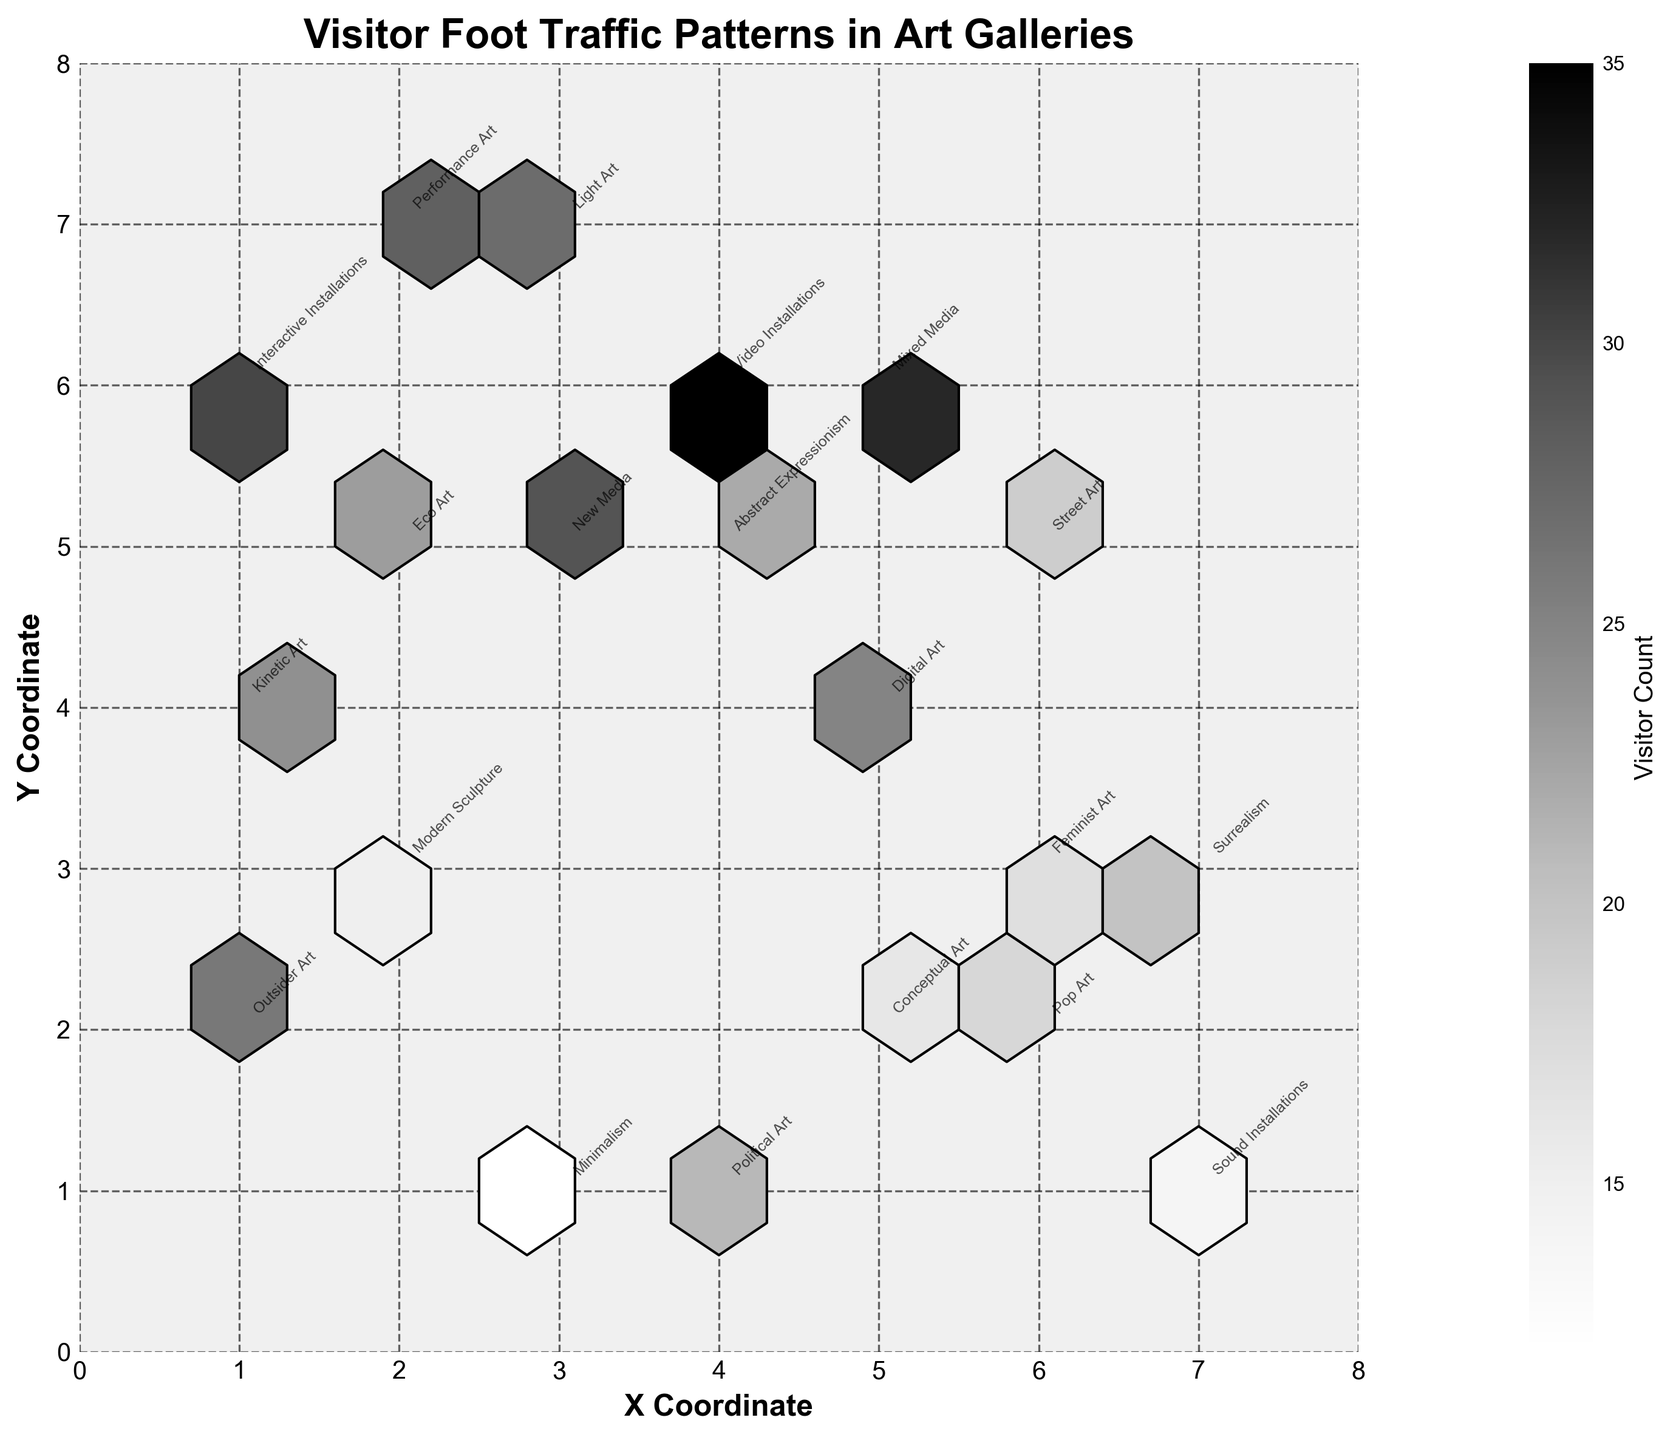What is the title of the plot? The title of the plot is displayed at the top of the figure.
Answer: Visitor Foot Traffic Patterns in Art Galleries What are the labels of the X and Y axes? The labels of the X and Y axes can be seen on the lower and left-hand sides of the plot, respectively.
Answer: X Coordinate, Y Coordinate How many bins show the highest visitor counts? To find the highest visitor counts, look at the darkest hexbin areas and count them.
Answer: 1 (Video Installations section) Which gallery section is located at (5, 4)? Look for the annotation at the coordinates (5, 4).
Answer: Digital Art What time of day does the Interactive Installations section have the highest visitor count? Check the annotation for the Interactive Installations section, then refer to the corresponding count and time_of_day.
Answer: 14:30 Which gallery section has the lowest visitor count? Identify the smallest number in the visitor counts and look for the associated gallery section.
Answer: Minimalism Between Conceptual Art and Eco Art, which gallery section has a higher visitor count? Compare the counts for Conceptual Art and Eco Art.
Answer: Eco Art What is the average visitor count across all gallery sections? Sum all counts and divide by the number of gallery sections.
Answer: 22 Is there a gallery section with a visitor count higher than 30? If so, name it. Look through the annotations and identify any sections with counts higher than 30.
Answer: Yes, Video Installations Which gallery sections have visitor counts between 10 and 20? Review the hexbin annotations to find sections with counts that fall within the specified range.
Answer: Surrealism, Street Art, Feminist Art, Minimalism, Sound Installations 